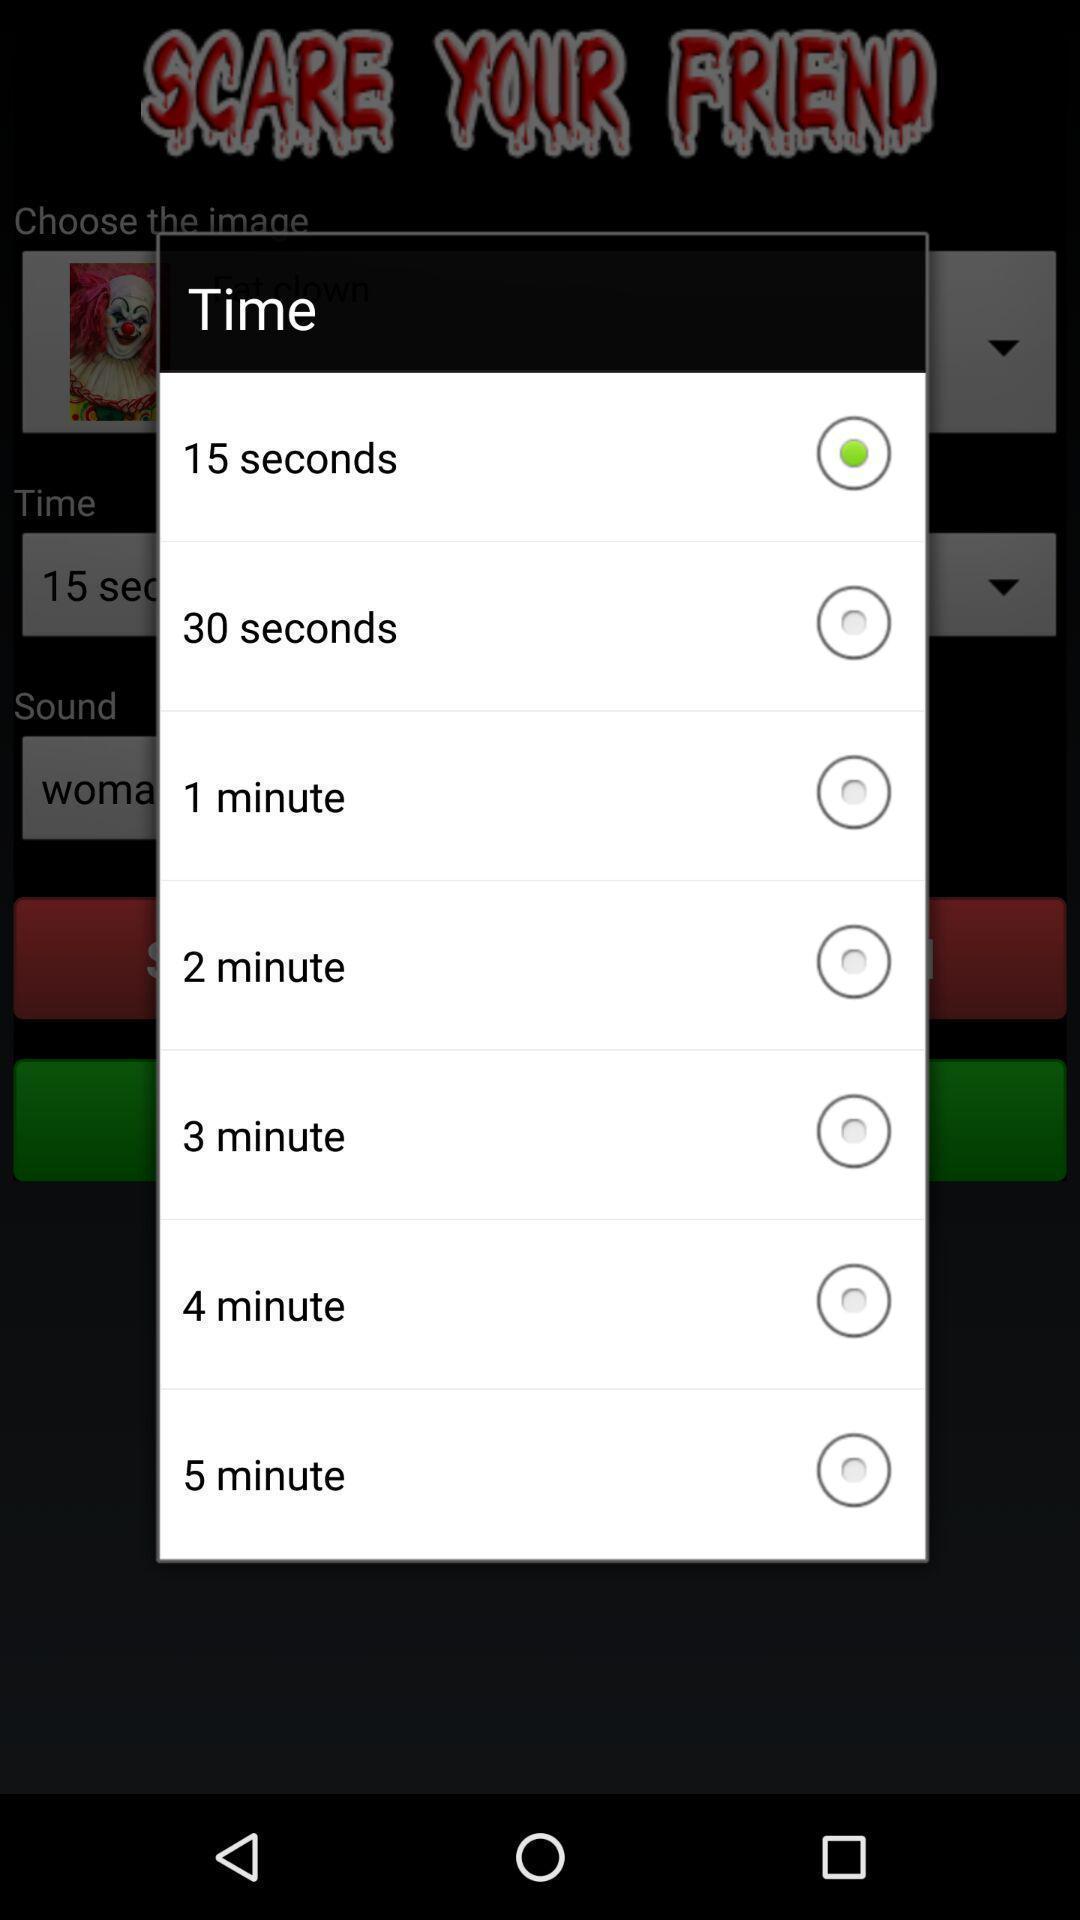Summarize the information in this screenshot. Popup to choose time in the app. 